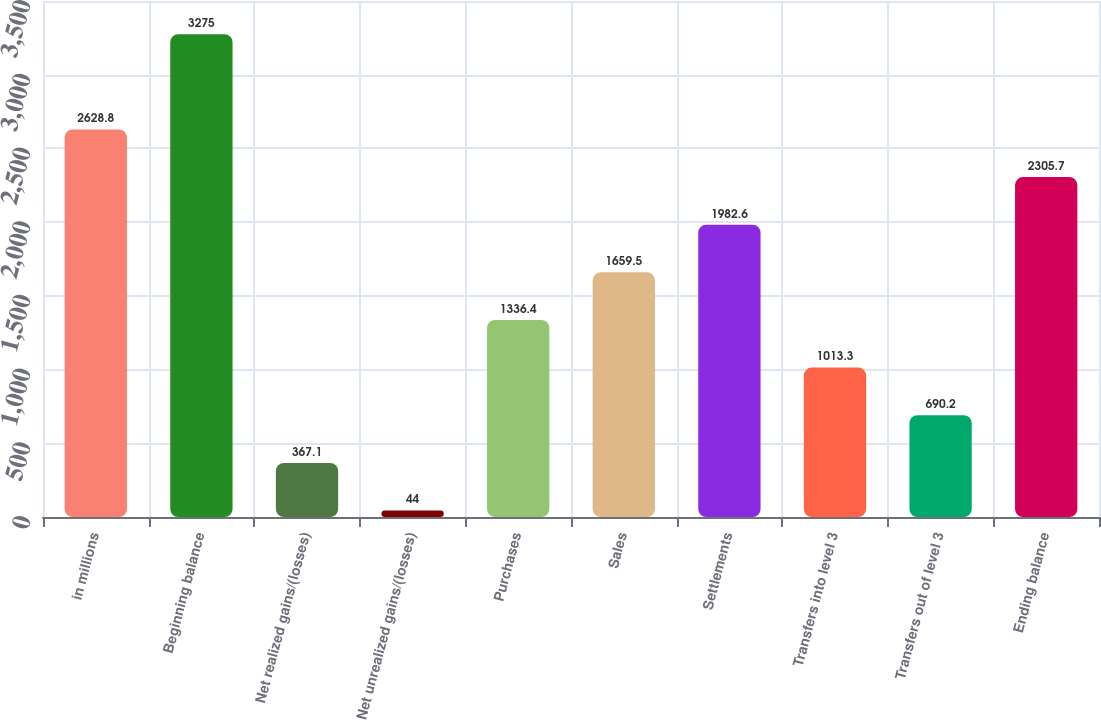<chart> <loc_0><loc_0><loc_500><loc_500><bar_chart><fcel>in millions<fcel>Beginning balance<fcel>Net realized gains/(losses)<fcel>Net unrealized gains/(losses)<fcel>Purchases<fcel>Sales<fcel>Settlements<fcel>Transfers into level 3<fcel>Transfers out of level 3<fcel>Ending balance<nl><fcel>2628.8<fcel>3275<fcel>367.1<fcel>44<fcel>1336.4<fcel>1659.5<fcel>1982.6<fcel>1013.3<fcel>690.2<fcel>2305.7<nl></chart> 